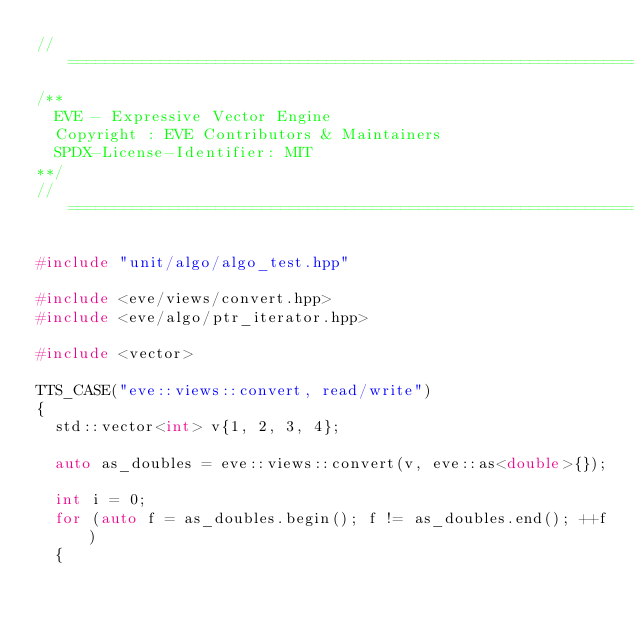Convert code to text. <code><loc_0><loc_0><loc_500><loc_500><_C++_>//==================================================================================================
/**
  EVE - Expressive Vector Engine
  Copyright : EVE Contributors & Maintainers
  SPDX-License-Identifier: MIT
**/
//==================================================================================================

#include "unit/algo/algo_test.hpp"

#include <eve/views/convert.hpp>
#include <eve/algo/ptr_iterator.hpp>

#include <vector>

TTS_CASE("eve::views::convert, read/write")
{
  std::vector<int> v{1, 2, 3, 4};

  auto as_doubles = eve::views::convert(v, eve::as<double>{});

  int i = 0;
  for (auto f = as_doubles.begin(); f != as_doubles.end(); ++f)
  {</code> 